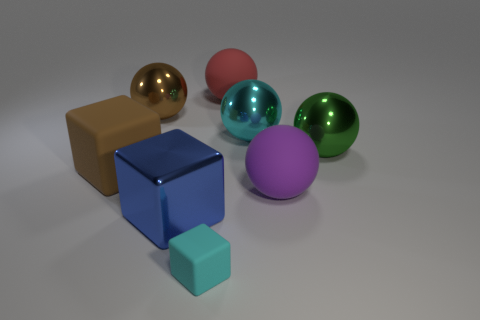Subtract all matte blocks. How many blocks are left? 1 Add 2 red rubber balls. How many objects exist? 10 Subtract all brown spheres. How many spheres are left? 4 Subtract all spheres. How many objects are left? 3 Subtract 1 blocks. How many blocks are left? 2 Subtract all purple blocks. Subtract all cyan cylinders. How many blocks are left? 3 Subtract all green blocks. How many purple balls are left? 1 Subtract all large purple shiny balls. Subtract all small cyan blocks. How many objects are left? 7 Add 1 large red matte objects. How many large red matte objects are left? 2 Add 2 big blue metal spheres. How many big blue metal spheres exist? 2 